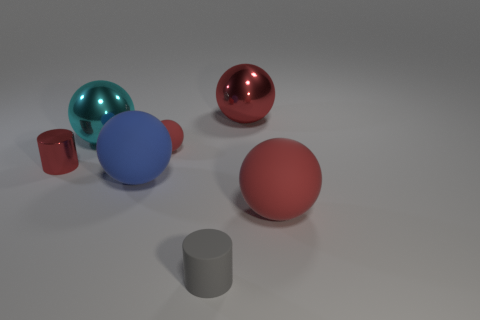Is there anything else that has the same shape as the tiny red metallic object?
Provide a short and direct response. Yes. Are there any tiny red things in front of the matte sphere to the right of the red rubber object behind the large blue object?
Provide a succinct answer. No. What number of big red balls have the same material as the blue thing?
Offer a terse response. 1. Do the red rubber object behind the tiny red metal cylinder and the ball that is in front of the blue ball have the same size?
Offer a very short reply. No. There is a big rubber object to the left of the matte object that is right of the large red shiny thing on the right side of the large blue matte ball; what color is it?
Give a very brief answer. Blue. Are there any large blue shiny things that have the same shape as the blue matte object?
Give a very brief answer. No. Are there an equal number of large spheres that are in front of the small red matte thing and matte balls that are on the right side of the big red matte sphere?
Your answer should be very brief. No. Does the small matte object that is to the right of the tiny ball have the same shape as the big red matte object?
Offer a terse response. No. Does the big red rubber object have the same shape as the blue matte thing?
Offer a terse response. Yes. What number of rubber things are large blue balls or tiny purple cylinders?
Make the answer very short. 1. 